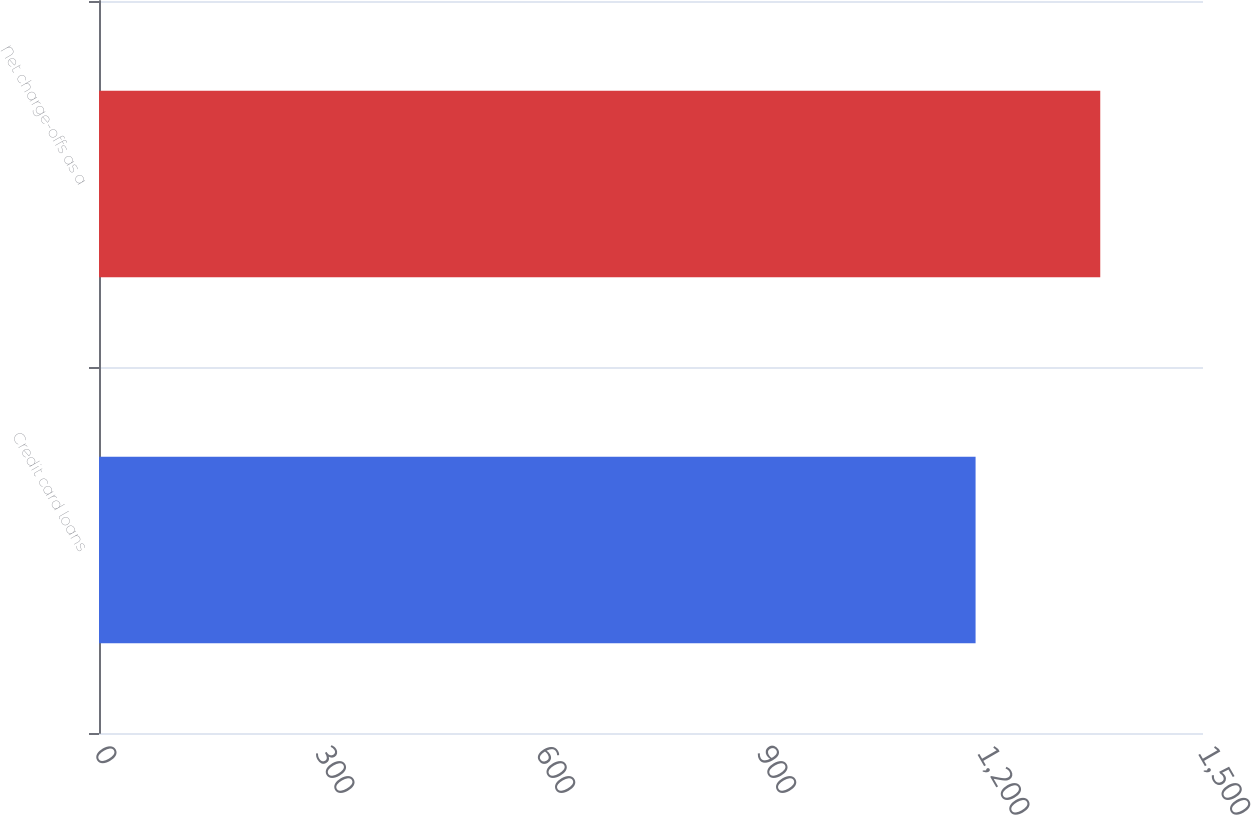<chart> <loc_0><loc_0><loc_500><loc_500><bar_chart><fcel>Credit card loans<fcel>Net charge-offs as a<nl><fcel>1191<fcel>1360.4<nl></chart> 